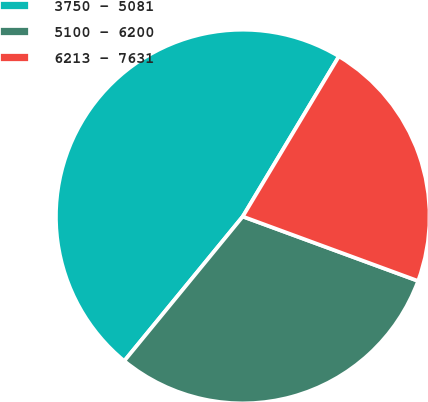Convert chart to OTSL. <chart><loc_0><loc_0><loc_500><loc_500><pie_chart><fcel>3750 - 5081<fcel>5100 - 6200<fcel>6213 - 7631<nl><fcel>47.67%<fcel>30.33%<fcel>22.0%<nl></chart> 